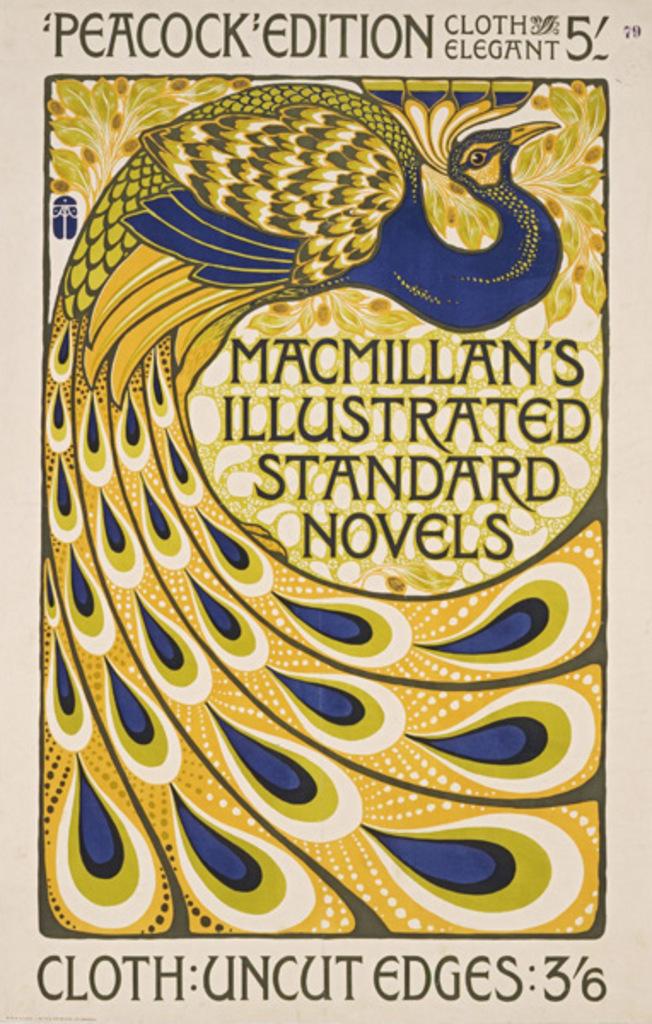What kind of edges does it have?
Ensure brevity in your answer.  Uncut. 